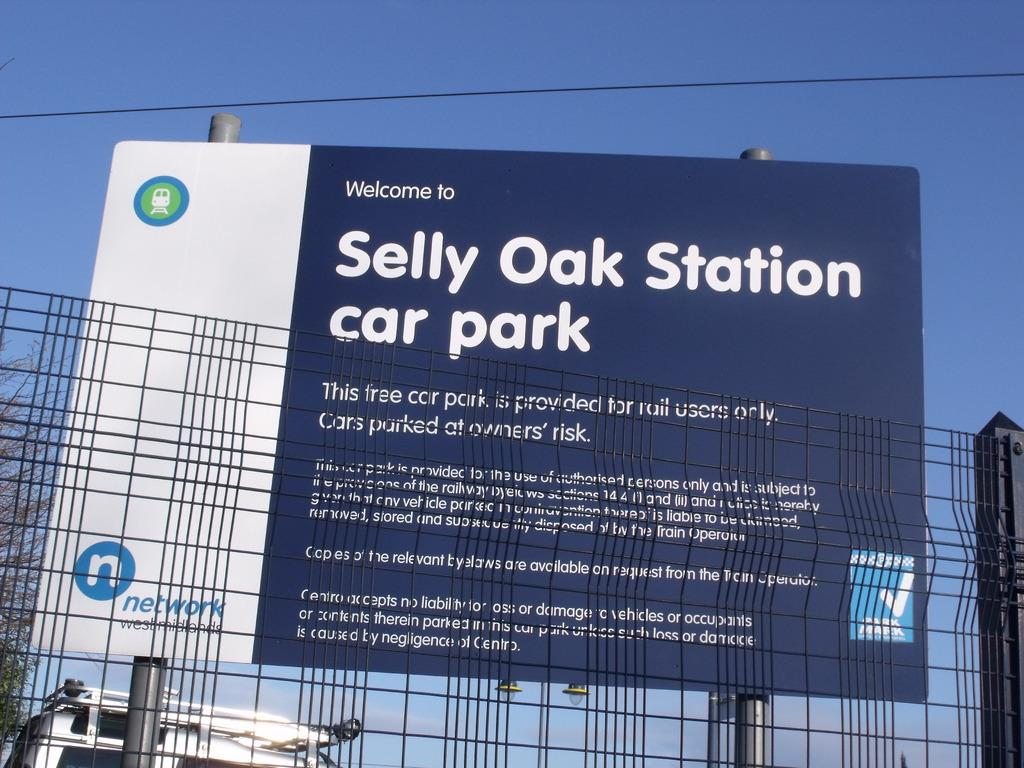Provide a one-sentence caption for the provided image. A sign behind a fence proclaims welocme to Selly Oak Station Car Park. 